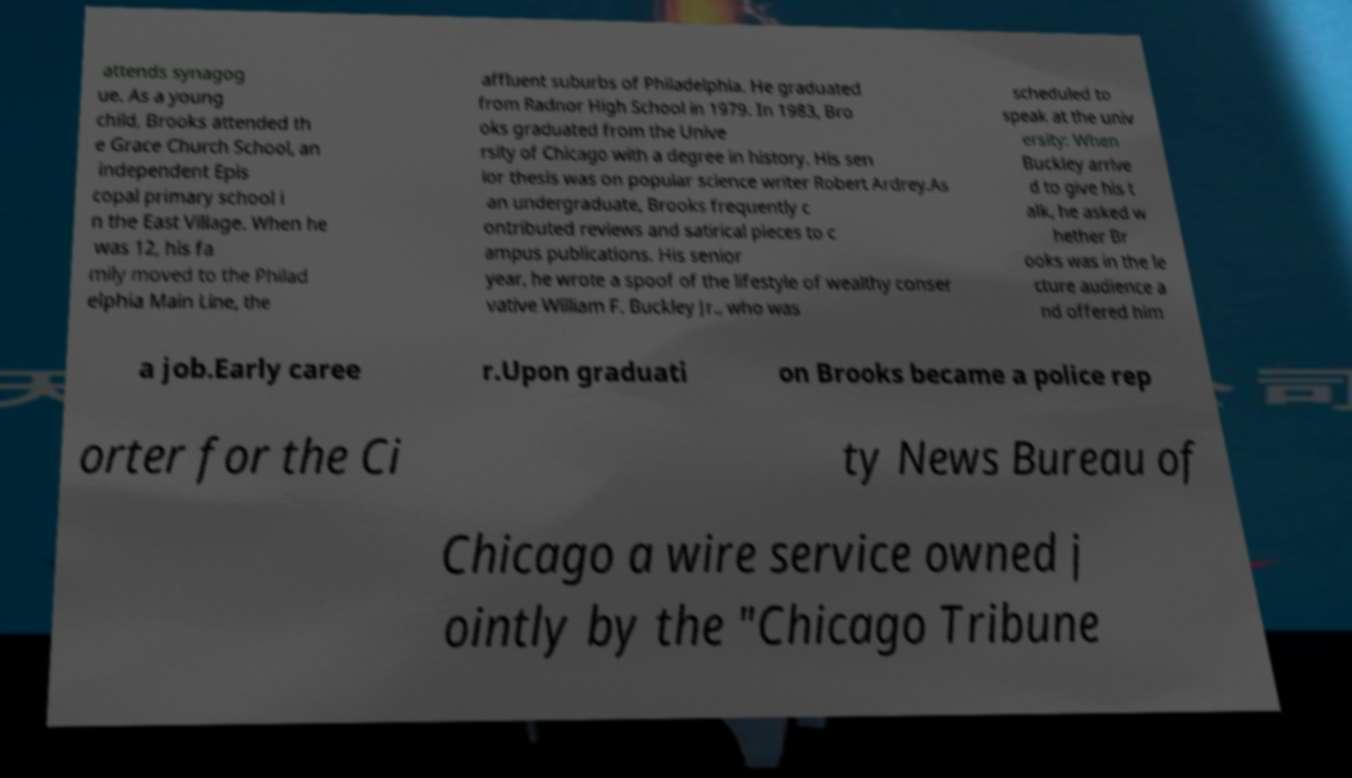Can you accurately transcribe the text from the provided image for me? attends synagog ue. As a young child, Brooks attended th e Grace Church School, an independent Epis copal primary school i n the East Village. When he was 12, his fa mily moved to the Philad elphia Main Line, the affluent suburbs of Philadelphia. He graduated from Radnor High School in 1979. In 1983, Bro oks graduated from the Unive rsity of Chicago with a degree in history. His sen ior thesis was on popular science writer Robert Ardrey.As an undergraduate, Brooks frequently c ontributed reviews and satirical pieces to c ampus publications. His senior year, he wrote a spoof of the lifestyle of wealthy conser vative William F. Buckley Jr., who was scheduled to speak at the univ ersity: When Buckley arrive d to give his t alk, he asked w hether Br ooks was in the le cture audience a nd offered him a job.Early caree r.Upon graduati on Brooks became a police rep orter for the Ci ty News Bureau of Chicago a wire service owned j ointly by the "Chicago Tribune 